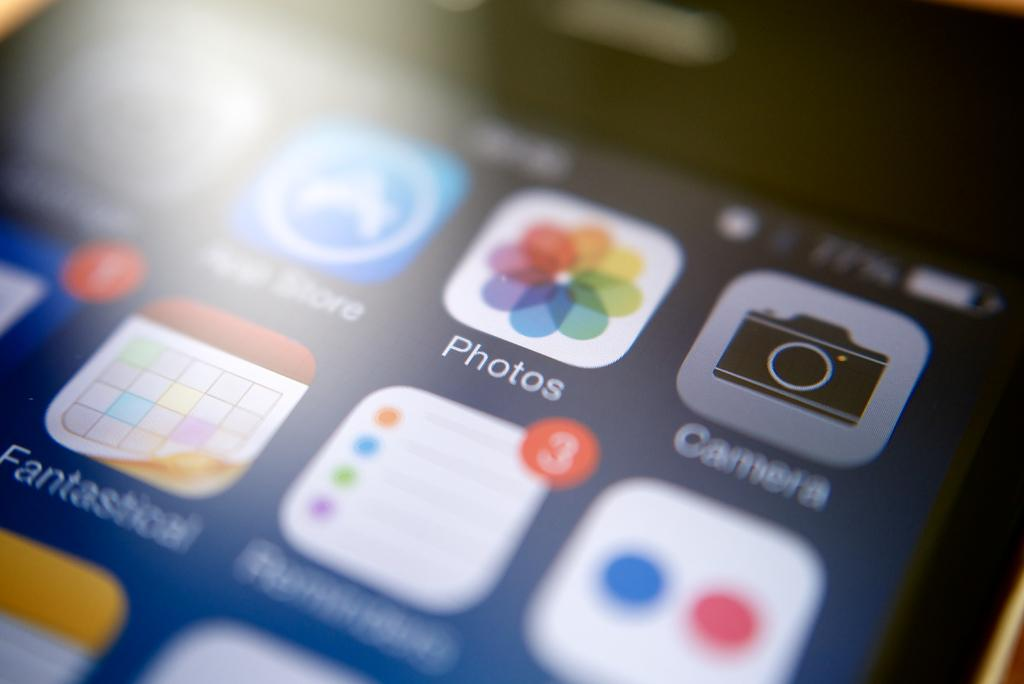Provide a one-sentence caption for the provided image. The app screen on a phone showing photos and camera icons. 